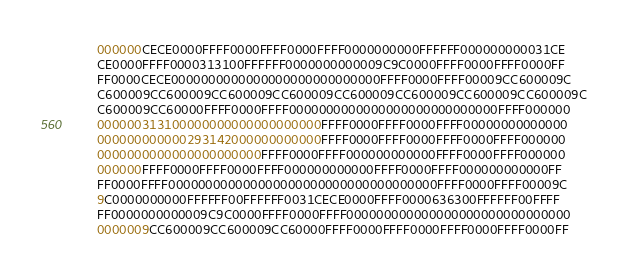<code> <loc_0><loc_0><loc_500><loc_500><_Pascal_>      000000CECE0000FFFF0000FFFF0000FFFF0000000000FFFFFF000000000031CE
      CE0000FFFF0000313100FFFFFF0000000000009C9C0000FFFF0000FFFF0000FF
      FF0000CECE0000000000000000000000000000FFFF0000FFFF00009CC600009C
      C600009CC600009CC600009CC600009CC600009CC600009CC600009CC600009C
      C600009CC60000FFFF0000FFFF0000000000000000000000000000FFFF000000
      000000313100000000000000000000FFFF0000FFFF0000FFFF00000000000000
      000000000000293142000000000000FFFF0000FFFF0000FFFF0000FFFF000000
      0000000000000000000000FFFF0000FFFF000000000000FFFF0000FFFF000000
      000000FFFF0000FFFF0000FFFF000000000000FFFF0000FFFF000000000000FF
      FF0000FFFF000000000000000000000000000000000000FFFF0000FFFF00009C
      9C0000000000FFFFFF00FFFFFF0031CECE0000FFFF0000636300FFFFFF00FFFF
      FF0000000000009C9C0000FFFF0000FFFF000000000000000000000000000000
      0000009CC600009CC600009CC60000FFFF0000FFFF0000FFFF0000FFFF0000FF</code> 